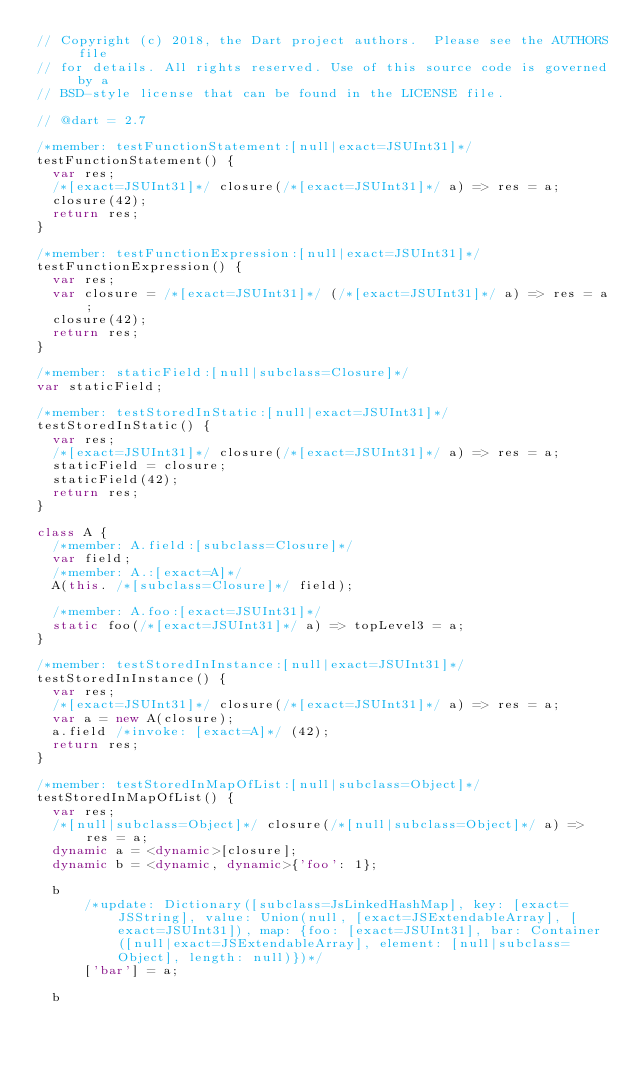Convert code to text. <code><loc_0><loc_0><loc_500><loc_500><_Dart_>// Copyright (c) 2018, the Dart project authors.  Please see the AUTHORS file
// for details. All rights reserved. Use of this source code is governed by a
// BSD-style license that can be found in the LICENSE file.

// @dart = 2.7

/*member: testFunctionStatement:[null|exact=JSUInt31]*/
testFunctionStatement() {
  var res;
  /*[exact=JSUInt31]*/ closure(/*[exact=JSUInt31]*/ a) => res = a;
  closure(42);
  return res;
}

/*member: testFunctionExpression:[null|exact=JSUInt31]*/
testFunctionExpression() {
  var res;
  var closure = /*[exact=JSUInt31]*/ (/*[exact=JSUInt31]*/ a) => res = a;
  closure(42);
  return res;
}

/*member: staticField:[null|subclass=Closure]*/
var staticField;

/*member: testStoredInStatic:[null|exact=JSUInt31]*/
testStoredInStatic() {
  var res;
  /*[exact=JSUInt31]*/ closure(/*[exact=JSUInt31]*/ a) => res = a;
  staticField = closure;
  staticField(42);
  return res;
}

class A {
  /*member: A.field:[subclass=Closure]*/
  var field;
  /*member: A.:[exact=A]*/
  A(this. /*[subclass=Closure]*/ field);

  /*member: A.foo:[exact=JSUInt31]*/
  static foo(/*[exact=JSUInt31]*/ a) => topLevel3 = a;
}

/*member: testStoredInInstance:[null|exact=JSUInt31]*/
testStoredInInstance() {
  var res;
  /*[exact=JSUInt31]*/ closure(/*[exact=JSUInt31]*/ a) => res = a;
  var a = new A(closure);
  a.field /*invoke: [exact=A]*/ (42);
  return res;
}

/*member: testStoredInMapOfList:[null|subclass=Object]*/
testStoredInMapOfList() {
  var res;
  /*[null|subclass=Object]*/ closure(/*[null|subclass=Object]*/ a) => res = a;
  dynamic a = <dynamic>[closure];
  dynamic b = <dynamic, dynamic>{'foo': 1};

  b
      /*update: Dictionary([subclass=JsLinkedHashMap], key: [exact=JSString], value: Union(null, [exact=JSExtendableArray], [exact=JSUInt31]), map: {foo: [exact=JSUInt31], bar: Container([null|exact=JSExtendableArray], element: [null|subclass=Object], length: null)})*/
      ['bar'] = a;

  b</code> 